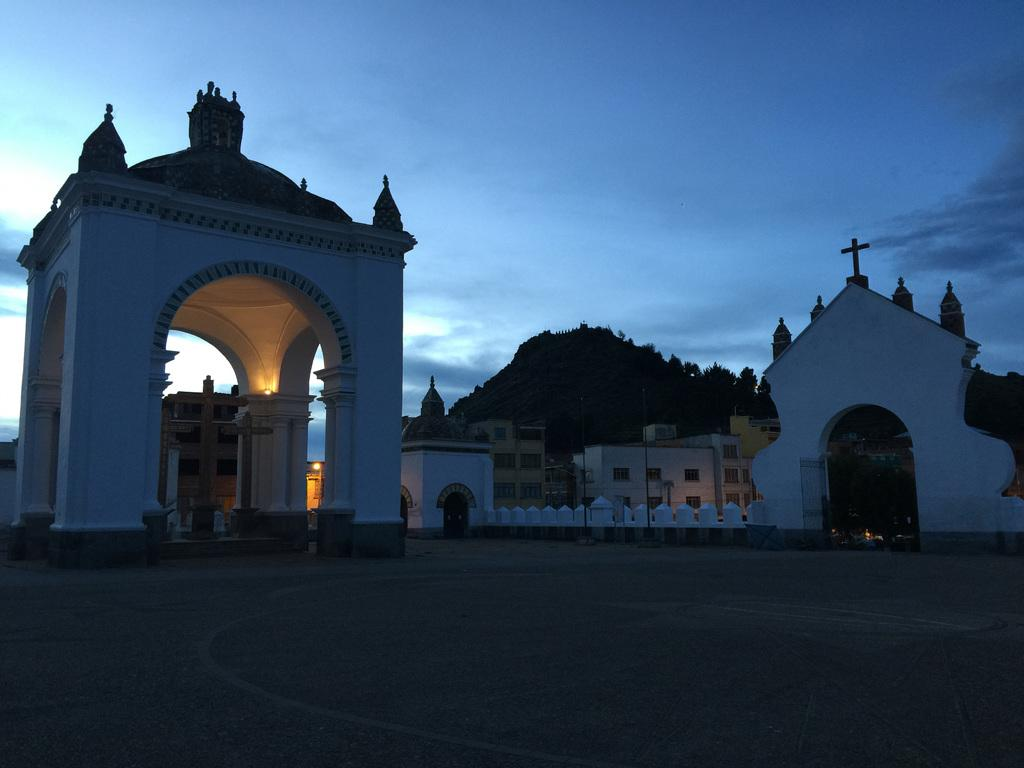What type of structures can be seen in the image? There are buildings in the image. What other natural elements are present in the image? There are trees in the image. What can be seen in the distance in the image? The sky is visible in the background of the image. What hobbies do the friends in the image enjoy? There are no friends or hobbies mentioned in the image; it only features buildings, trees, and the sky. 